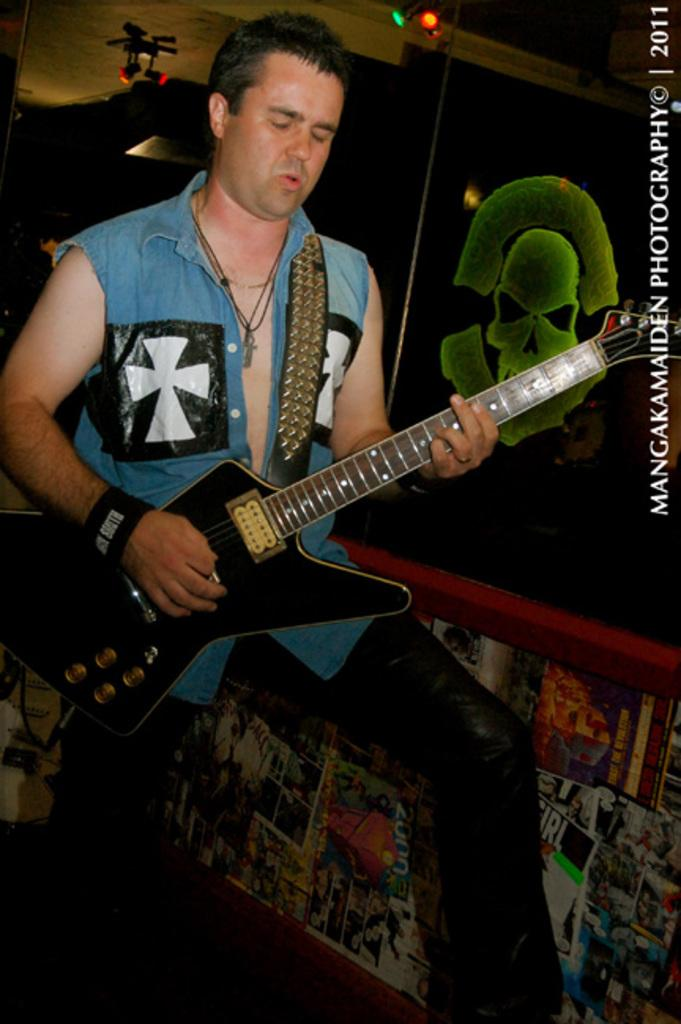What is the man in the image doing? The man is playing a guitar. What is the man wearing in the image? The man is wearing a blue shirt. What can be seen on the wall in the background of the image? There are posters on the wall in the background. What is visible at the top of the image? There is a roof visible at the top of the image. What type of salt is being used to play the guitar in the image? There is no salt present in the image, and the man is playing the guitar with his hands, not salt. 